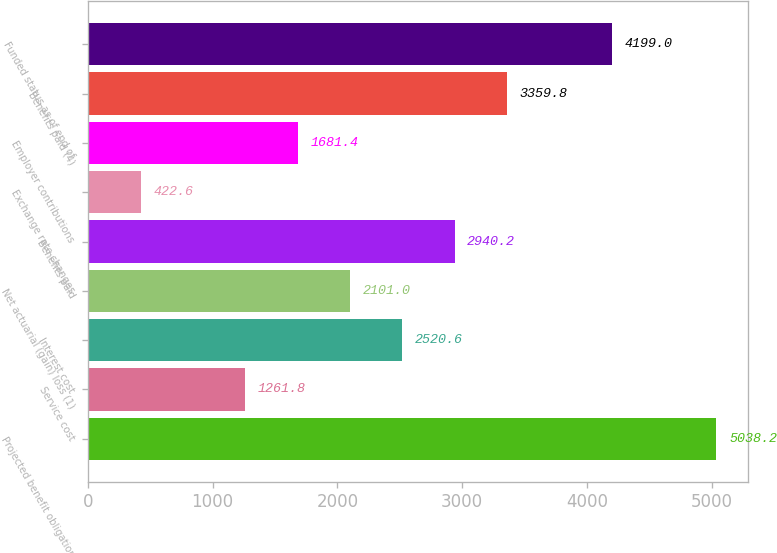<chart> <loc_0><loc_0><loc_500><loc_500><bar_chart><fcel>Projected benefit obligation<fcel>Service cost<fcel>Interest cost<fcel>Net actuarial (gain) loss (1)<fcel>Benefits paid<fcel>Exchange rate changes<fcel>Employer contributions<fcel>Benefits paid (4)<fcel>Funded status as of end of<nl><fcel>5038.2<fcel>1261.8<fcel>2520.6<fcel>2101<fcel>2940.2<fcel>422.6<fcel>1681.4<fcel>3359.8<fcel>4199<nl></chart> 